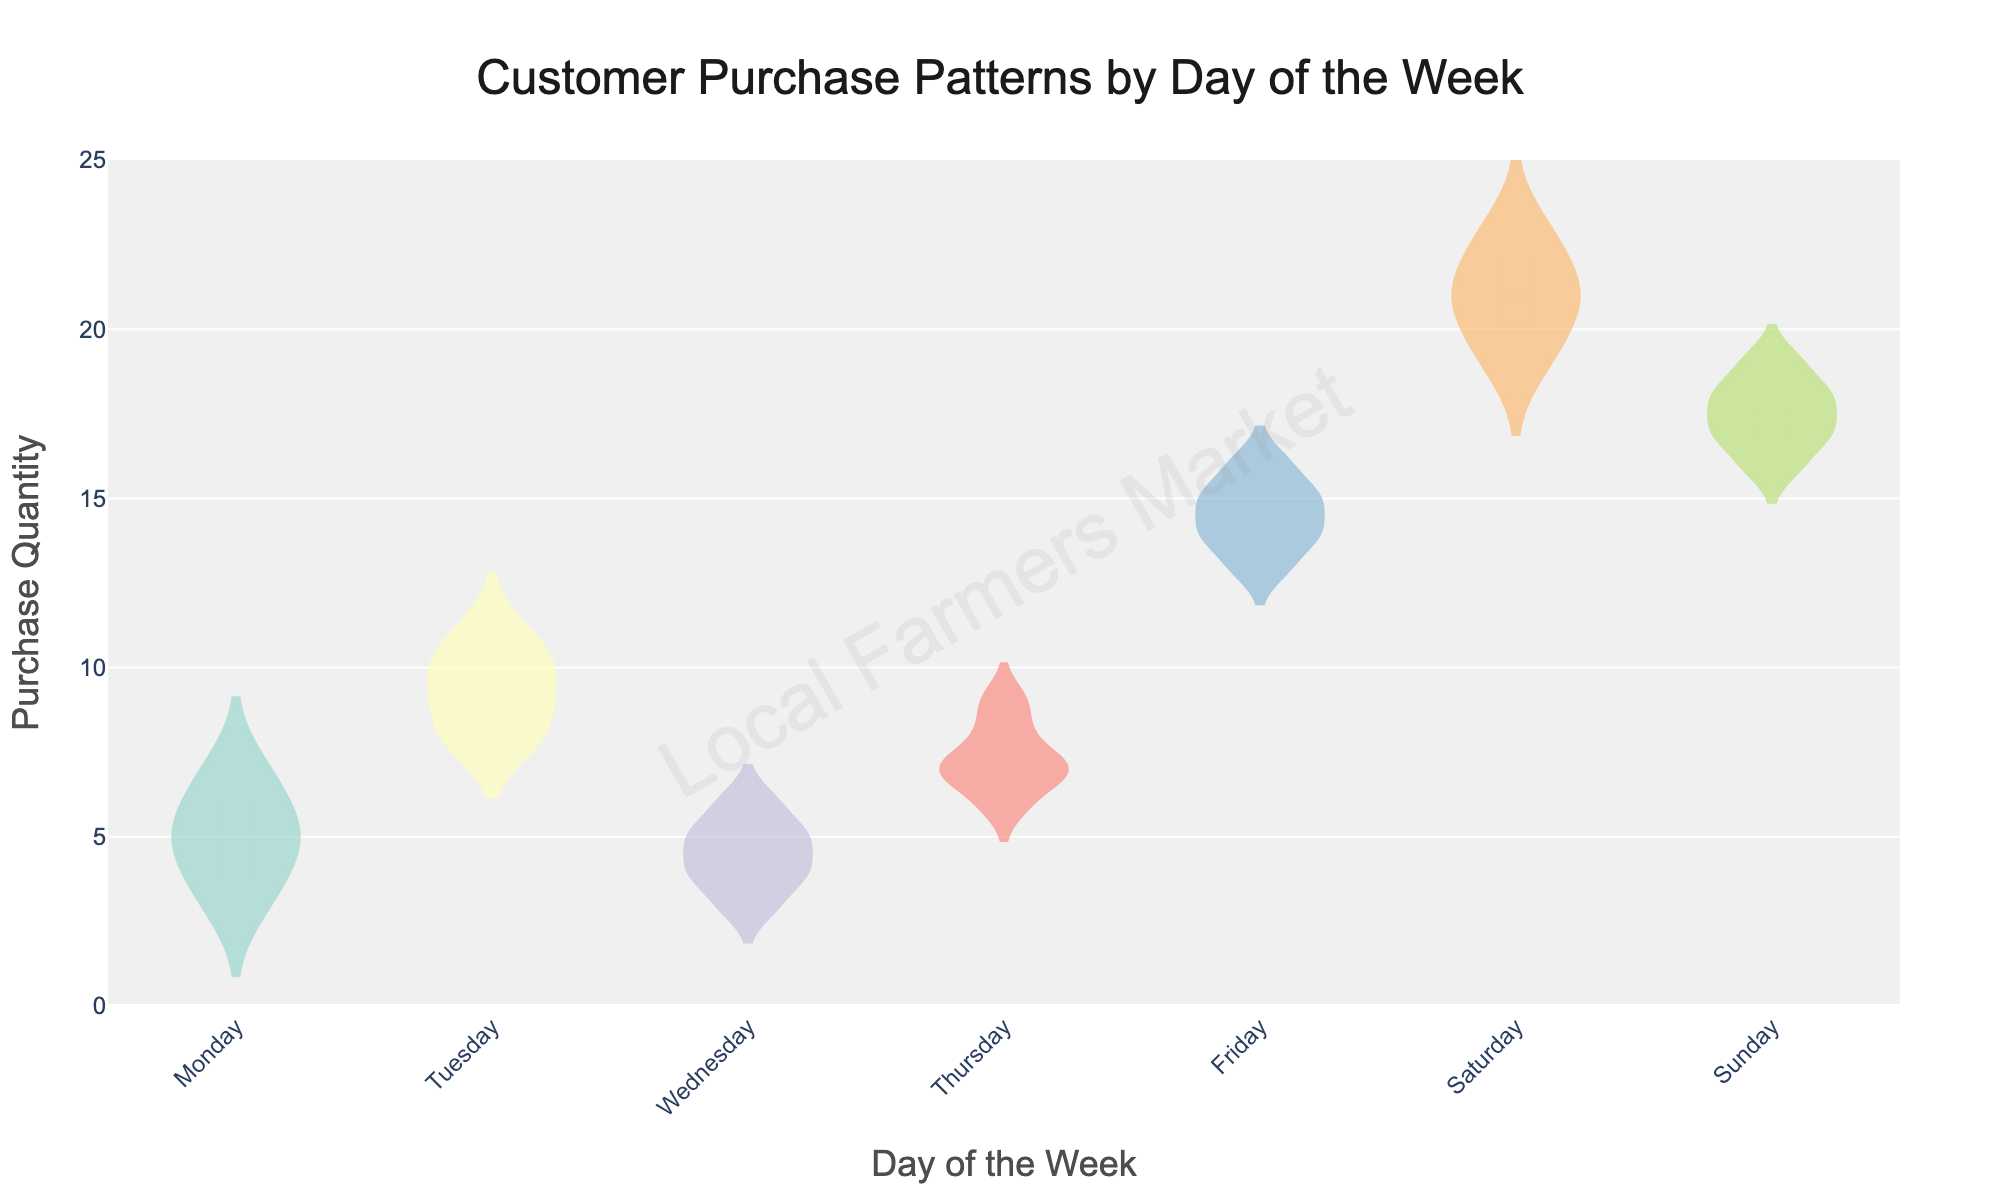What's the highest median purchase quantity among the days? By looking at the box plot overlay on each violin plot, identify the median line position. Saturday has the highest median, visible as the horizontal line in the box plot.
Answer: Saturday Which day has the lowest interquartile range (IQR)? The IQR is the length of the box in the box plot overlay. Monday and Sunday have relatively shorter boxes compared to other days, indicating a smaller IQR.
Answer: Monday and Sunday On which day is the mean purchase quantity closest to the median? The mean is indicated by the line inside the violin plot, and the median is the line in the box plot. On Saturday, the mean and median are closest to each other.
Answer: Saturday Which day has the widest distribution of purchase quantities? The widest distribution can be seen by observing the width of the violin plot. Saturday shows the widest spread.
Answer: Saturday Compare the average purchase quantity on Monday to Tuesday. Which day is higher? The average is indicated by the line in the box plot. The Tuesday plot's mean line is significantly higher than that of Monday.
Answer: Tuesday What is the range of purchase quantities on Wednesday? The range is the distance from the lowest to the highest value shown in the violin plot. For Wednesday, it goes from 3 to 6.
Answer: 3 to 6 Is the median purchase quantity on Thursday higher than on Wednesday? By comparing the median lines in the box plot overlay, Thursday's median is higher than Wednesday's.
Answer: Yes Which day shows the most skewed distribution? Skewness can be observed by looking at the asymmetry of the violin plot. Sunday appears to have a more symmetrical distribution compared to other days.
Answer: Sunday What is the mode of the purchase quantity on Friday? Based on the violin plot density, the mode is the value with the highest peak. For Friday, it seems to be around 15.
Answer: 15 